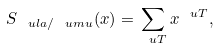<formula> <loc_0><loc_0><loc_500><loc_500>S _ { \ u l a / \ u m u } ( x ) = \sum _ { \ u T } x ^ { \ u T } ,</formula> 